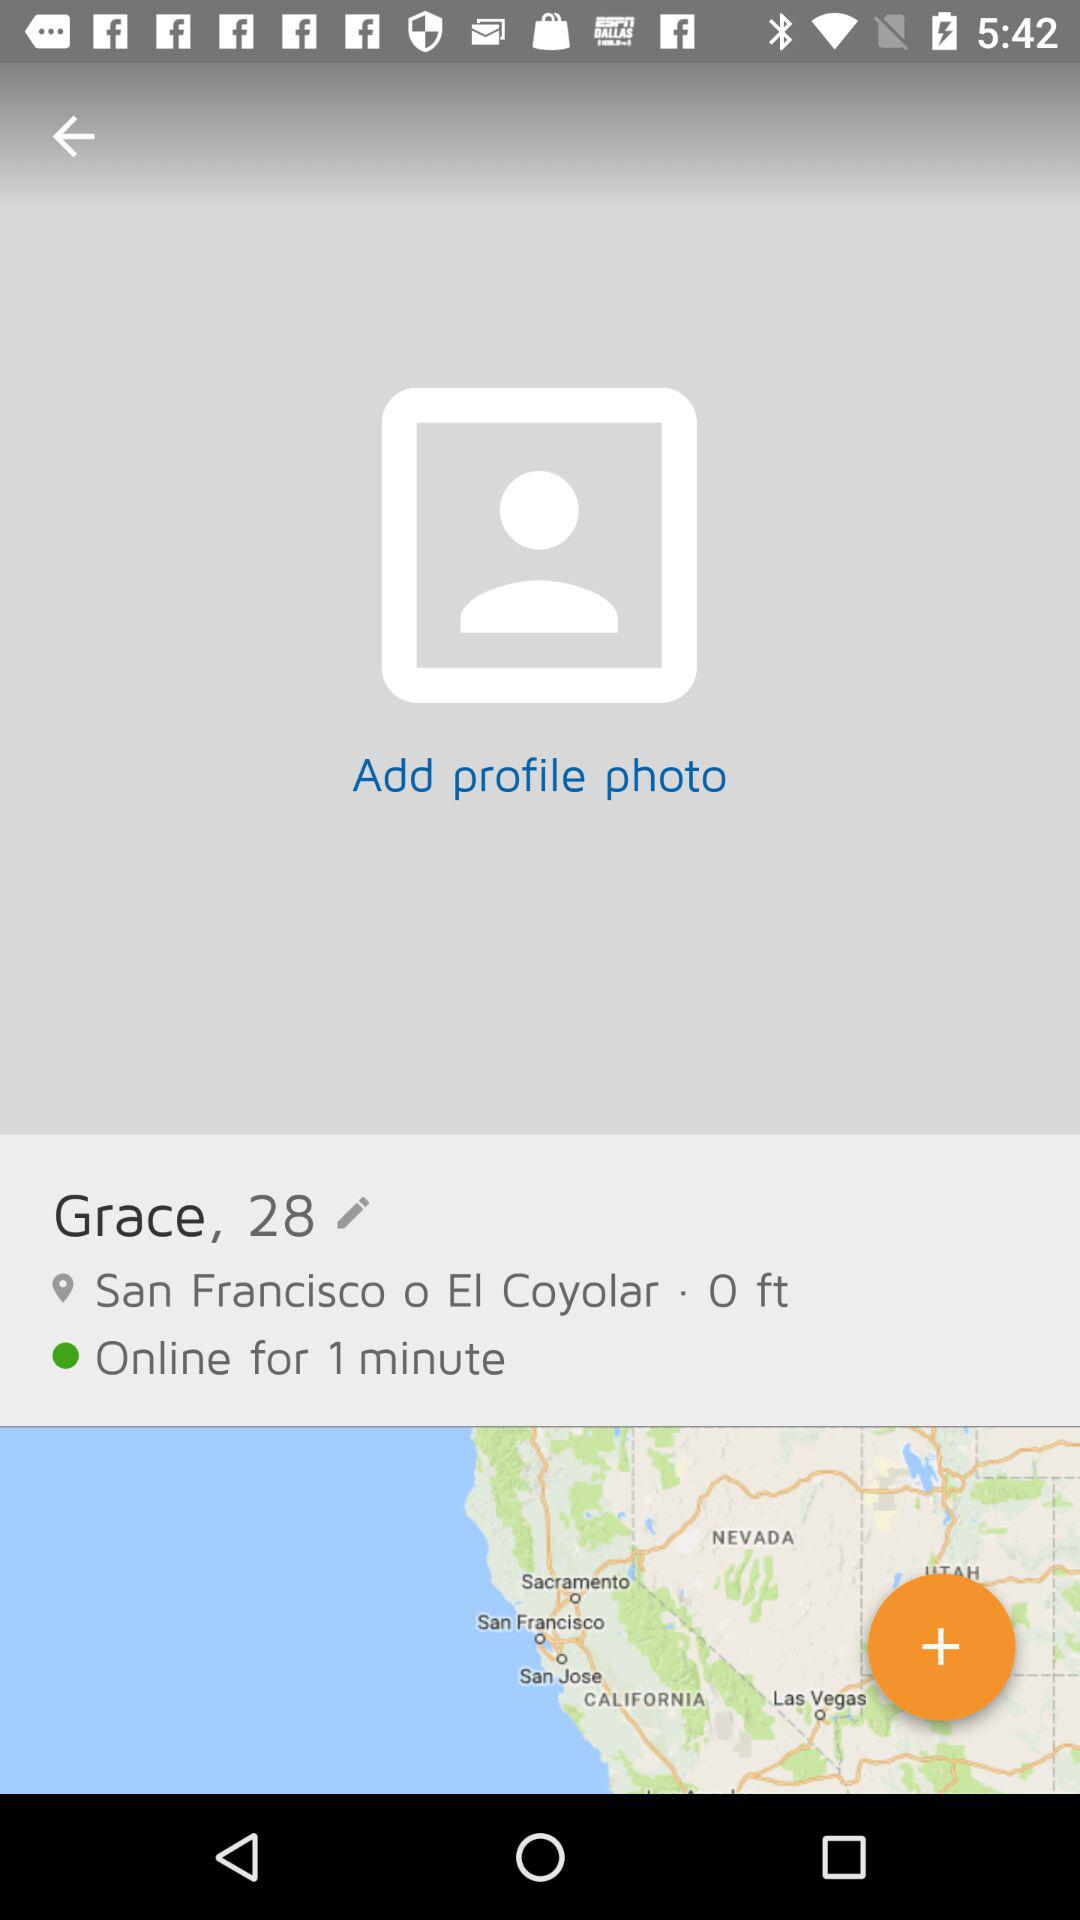What is the name of the user? The name of the user is Grace. 